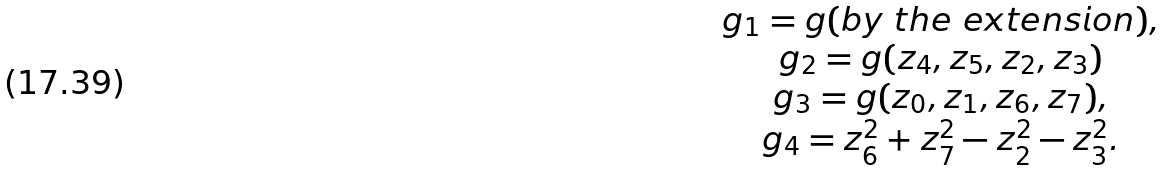Convert formula to latex. <formula><loc_0><loc_0><loc_500><loc_500>\begin{array} { c } g _ { 1 } = g ( b y \ t h e \ e x t e n s i o n ) , \\ g _ { 2 } = g ( z _ { 4 } , z _ { 5 } , z _ { 2 } , z _ { 3 } ) \\ g _ { 3 } = g ( z _ { 0 } , z _ { 1 } , z _ { 6 } , z _ { 7 } ) , \\ g _ { 4 } = z _ { 6 } ^ { 2 } + z _ { 7 } ^ { 2 } - z _ { 2 } ^ { 2 } - z _ { 3 } ^ { 2 } . \end{array}</formula> 